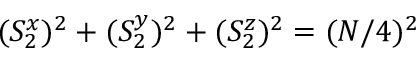Convert formula to latex. <formula><loc_0><loc_0><loc_500><loc_500>( S _ { 2 } ^ { x } ) ^ { 2 } + ( S _ { 2 } ^ { y } ) ^ { 2 } + ( S _ { 2 } ^ { z } ) ^ { 2 } = ( N / 4 ) ^ { 2 }</formula> 